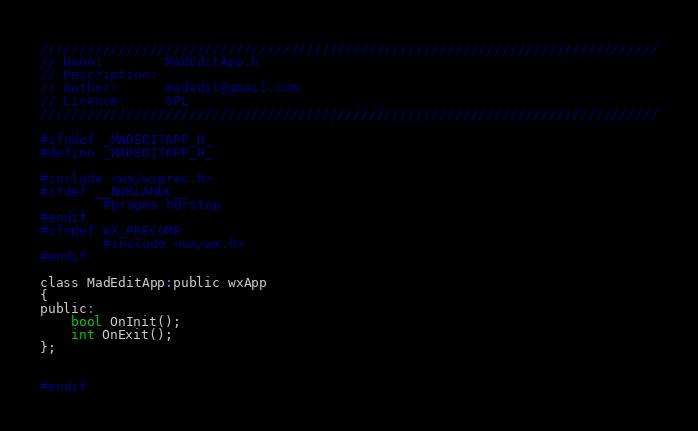<code> <loc_0><loc_0><loc_500><loc_500><_C_>///////////////////////////////////////////////////////////////////////////////
// Name:        MadEditApp.h
// Description:
// Author:      madedit@gmail.com
// Licence:     GPL
///////////////////////////////////////////////////////////////////////////////

#ifndef _MADEDITAPP_H_
#define _MADEDITAPP_H_

#include <wx/wxprec.h>
#ifdef __BORLANDC__
        #pragma hdrstop
#endif
#ifndef WX_PRECOMP
        #include <wx/wx.h>
#endif

class MadEditApp:public wxApp
{
public:
	bool OnInit();
	int OnExit();
};

 
#endif
</code> 